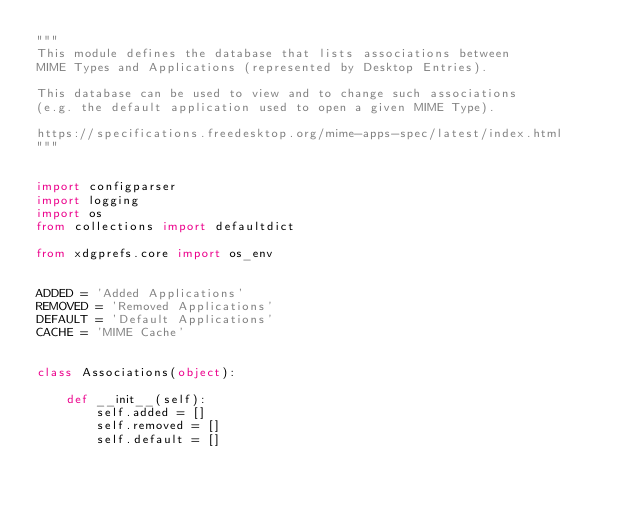<code> <loc_0><loc_0><loc_500><loc_500><_Python_>"""
This module defines the database that lists associations between
MIME Types and Applications (represented by Desktop Entries).

This database can be used to view and to change such associations
(e.g. the default application used to open a given MIME Type).

https://specifications.freedesktop.org/mime-apps-spec/latest/index.html
"""


import configparser
import logging
import os
from collections import defaultdict

from xdgprefs.core import os_env


ADDED = 'Added Applications'
REMOVED = 'Removed Applications'
DEFAULT = 'Default Applications'
CACHE = 'MIME Cache'


class Associations(object):

    def __init__(self):
        self.added = []
        self.removed = []
        self.default = []
</code> 